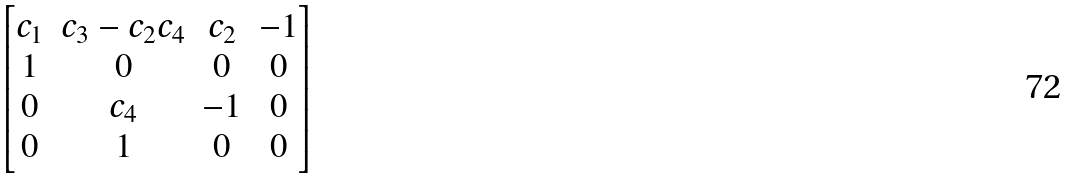Convert formula to latex. <formula><loc_0><loc_0><loc_500><loc_500>\begin{bmatrix} c _ { 1 } & c _ { 3 } - c _ { 2 } c _ { 4 } & c _ { 2 } & - 1 \\ 1 & 0 & 0 & 0 \\ 0 & c _ { 4 } & - 1 & 0 \\ 0 & 1 & 0 & 0 \end{bmatrix}</formula> 